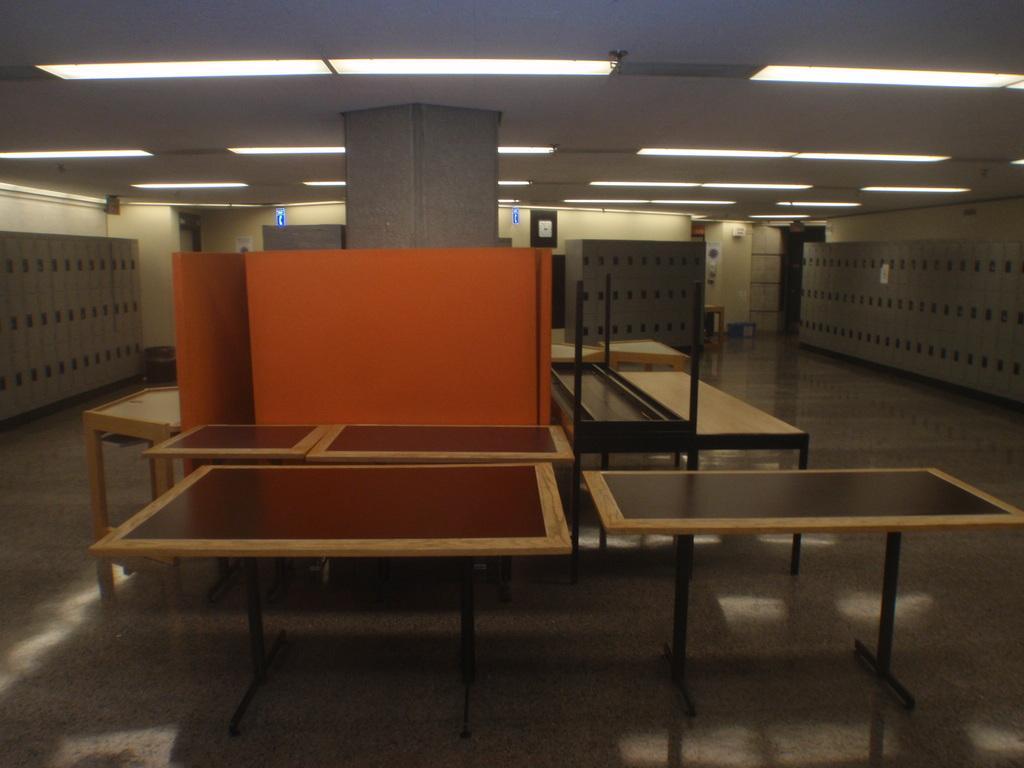How would you summarize this image in a sentence or two? In this picture we can see few tables, lockers and lights. 